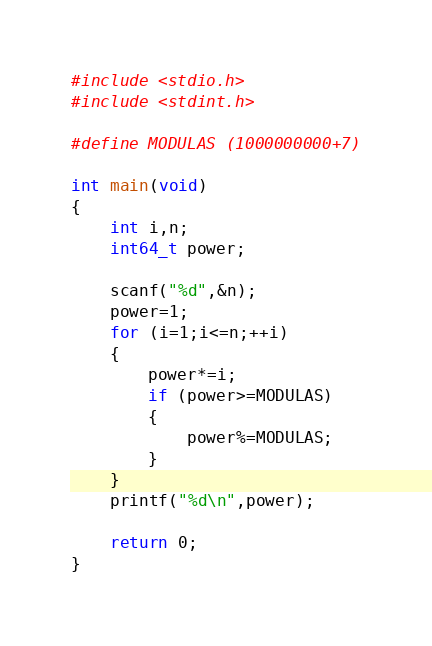Convert code to text. <code><loc_0><loc_0><loc_500><loc_500><_C_>#include <stdio.h>
#include <stdint.h>

#define MODULAS (1000000000+7)

int main(void)
{
	int i,n;
	int64_t power;

	scanf("%d",&n);
	power=1;
	for (i=1;i<=n;++i)
	{
		power*=i;
		if (power>=MODULAS)
		{
			power%=MODULAS;
		}
	}
	printf("%d\n",power);

	return 0;
}


</code> 